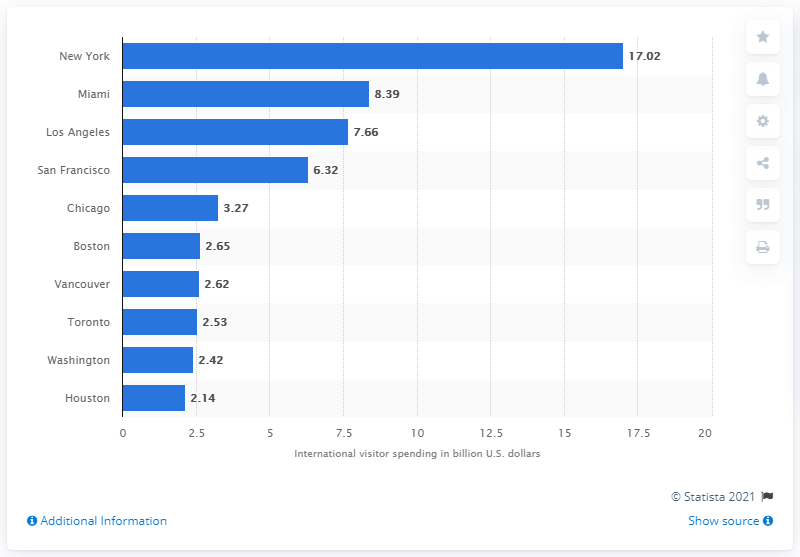Indicate a few pertinent items in this graphic. In 2016, the city of New York spent a significant amount of money on international visitors. In 2016, New York City had the highest amount of international visitor spending in North America. 